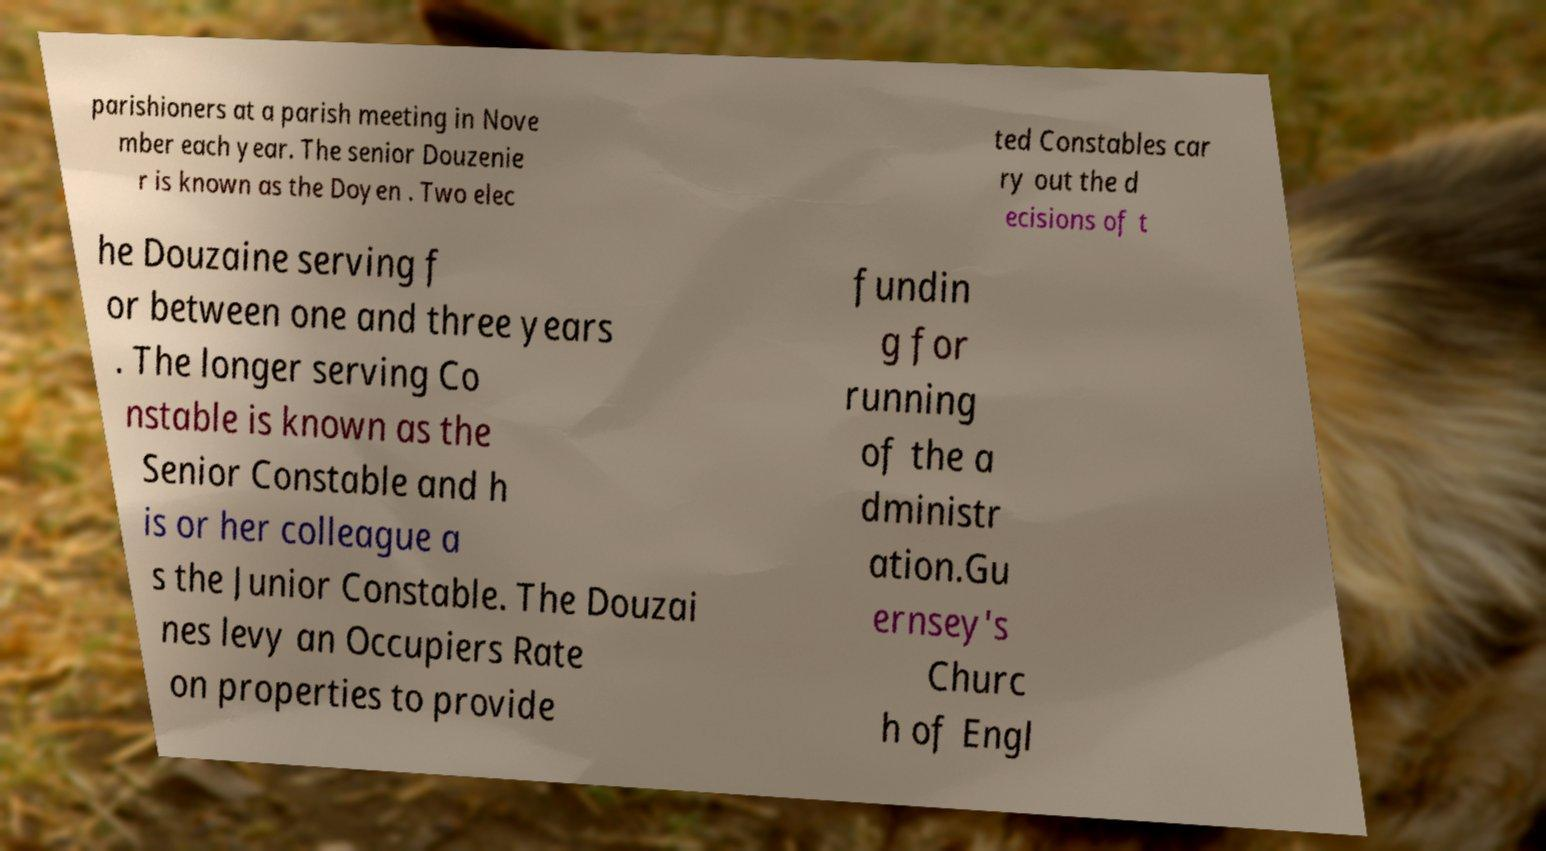Please read and relay the text visible in this image. What does it say? parishioners at a parish meeting in Nove mber each year. The senior Douzenie r is known as the Doyen . Two elec ted Constables car ry out the d ecisions of t he Douzaine serving f or between one and three years . The longer serving Co nstable is known as the Senior Constable and h is or her colleague a s the Junior Constable. The Douzai nes levy an Occupiers Rate on properties to provide fundin g for running of the a dministr ation.Gu ernsey's Churc h of Engl 